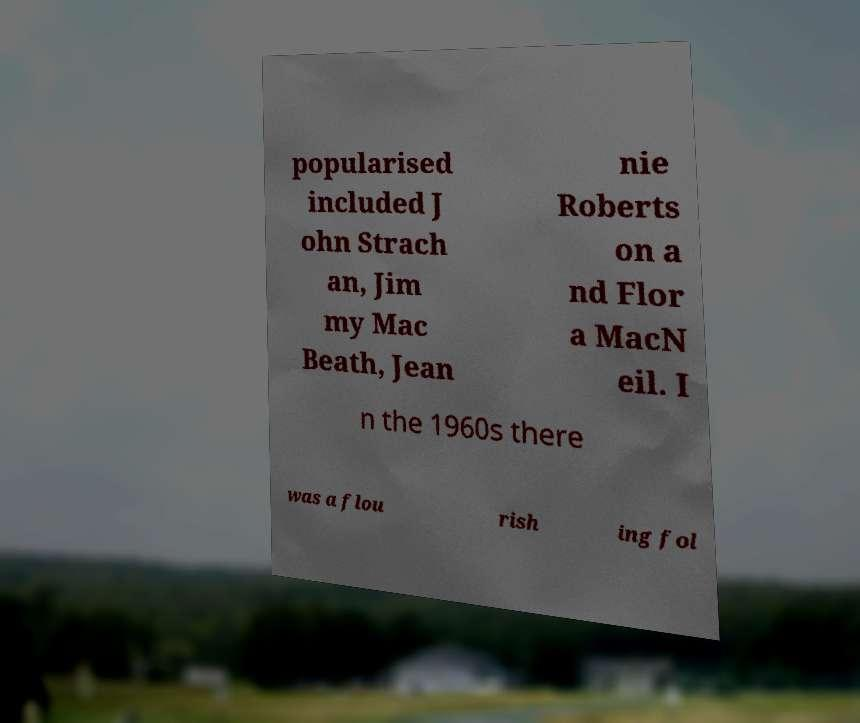For documentation purposes, I need the text within this image transcribed. Could you provide that? popularised included J ohn Strach an, Jim my Mac Beath, Jean nie Roberts on a nd Flor a MacN eil. I n the 1960s there was a flou rish ing fol 